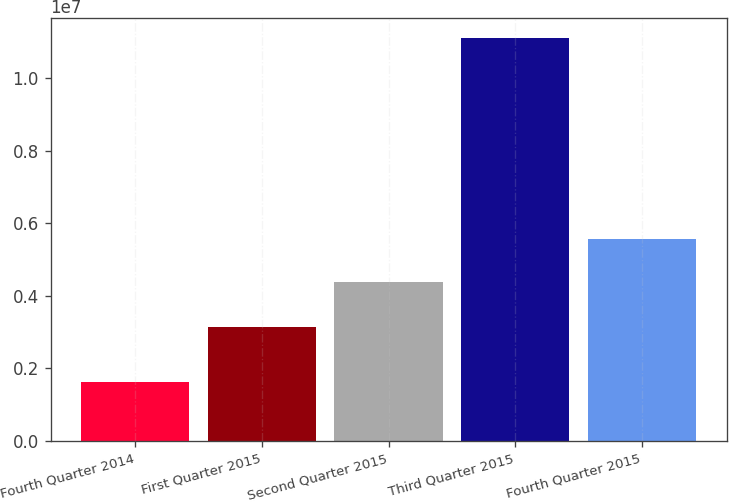Convert chart. <chart><loc_0><loc_0><loc_500><loc_500><bar_chart><fcel>Fourth Quarter 2014<fcel>First Quarter 2015<fcel>Second Quarter 2015<fcel>Third Quarter 2015<fcel>Fourth Quarter 2015<nl><fcel>1.62436e+06<fcel>3.14648e+06<fcel>4.37991e+06<fcel>1.11042e+07<fcel>5.55892e+06<nl></chart> 